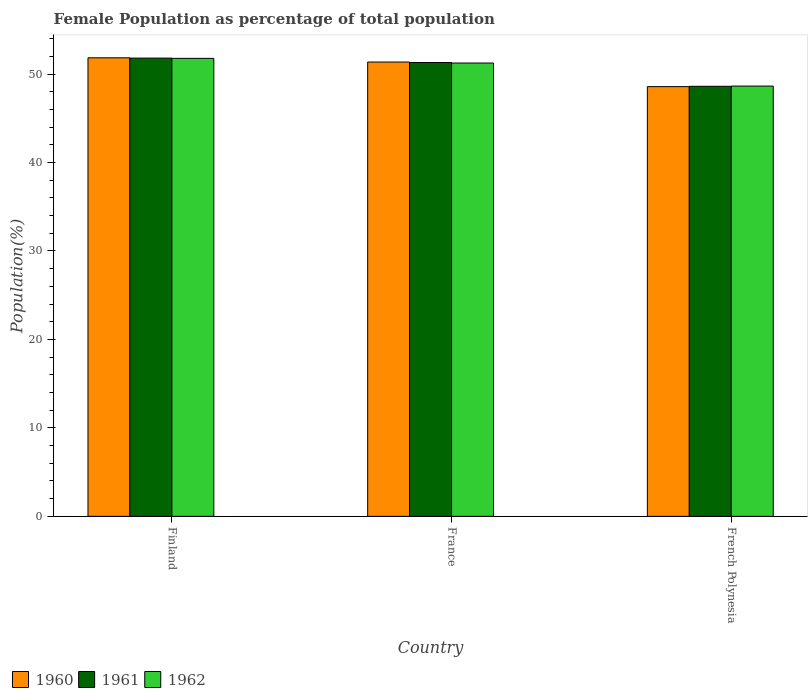How many different coloured bars are there?
Provide a succinct answer. 3. Are the number of bars per tick equal to the number of legend labels?
Your response must be concise. Yes. Are the number of bars on each tick of the X-axis equal?
Keep it short and to the point. Yes. How many bars are there on the 2nd tick from the left?
Provide a short and direct response. 3. How many bars are there on the 3rd tick from the right?
Offer a very short reply. 3. What is the label of the 1st group of bars from the left?
Ensure brevity in your answer.  Finland. What is the female population in in 1962 in France?
Provide a succinct answer. 51.25. Across all countries, what is the maximum female population in in 1960?
Your response must be concise. 51.84. Across all countries, what is the minimum female population in in 1960?
Make the answer very short. 48.58. In which country was the female population in in 1960 maximum?
Ensure brevity in your answer.  Finland. In which country was the female population in in 1962 minimum?
Offer a very short reply. French Polynesia. What is the total female population in in 1961 in the graph?
Offer a very short reply. 151.73. What is the difference between the female population in in 1960 in Finland and that in French Polynesia?
Ensure brevity in your answer.  3.26. What is the difference between the female population in in 1961 in French Polynesia and the female population in in 1962 in Finland?
Make the answer very short. -3.16. What is the average female population in in 1960 per country?
Provide a short and direct response. 50.59. What is the difference between the female population in of/in 1960 and female population in of/in 1962 in Finland?
Your response must be concise. 0.06. What is the ratio of the female population in in 1961 in Finland to that in France?
Your answer should be compact. 1.01. Is the female population in in 1961 in France less than that in French Polynesia?
Your response must be concise. No. Is the difference between the female population in in 1960 in Finland and French Polynesia greater than the difference between the female population in in 1962 in Finland and French Polynesia?
Provide a short and direct response. Yes. What is the difference between the highest and the second highest female population in in 1961?
Your response must be concise. -2.69. What is the difference between the highest and the lowest female population in in 1962?
Provide a short and direct response. 3.13. What does the 1st bar from the left in French Polynesia represents?
Your answer should be very brief. 1960. Is it the case that in every country, the sum of the female population in in 1960 and female population in in 1962 is greater than the female population in in 1961?
Give a very brief answer. Yes. Does the graph contain grids?
Make the answer very short. No. Where does the legend appear in the graph?
Your answer should be very brief. Bottom left. How many legend labels are there?
Provide a short and direct response. 3. What is the title of the graph?
Offer a terse response. Female Population as percentage of total population. What is the label or title of the X-axis?
Offer a terse response. Country. What is the label or title of the Y-axis?
Make the answer very short. Population(%). What is the Population(%) in 1960 in Finland?
Provide a succinct answer. 51.84. What is the Population(%) in 1961 in Finland?
Provide a succinct answer. 51.81. What is the Population(%) of 1962 in Finland?
Give a very brief answer. 51.77. What is the Population(%) in 1960 in France?
Provide a succinct answer. 51.36. What is the Population(%) in 1961 in France?
Your response must be concise. 51.31. What is the Population(%) in 1962 in France?
Offer a terse response. 51.25. What is the Population(%) in 1960 in French Polynesia?
Offer a terse response. 48.58. What is the Population(%) of 1961 in French Polynesia?
Your response must be concise. 48.62. What is the Population(%) in 1962 in French Polynesia?
Give a very brief answer. 48.64. Across all countries, what is the maximum Population(%) of 1960?
Your response must be concise. 51.84. Across all countries, what is the maximum Population(%) of 1961?
Provide a short and direct response. 51.81. Across all countries, what is the maximum Population(%) in 1962?
Offer a very short reply. 51.77. Across all countries, what is the minimum Population(%) of 1960?
Your response must be concise. 48.58. Across all countries, what is the minimum Population(%) of 1961?
Offer a very short reply. 48.62. Across all countries, what is the minimum Population(%) in 1962?
Your answer should be compact. 48.64. What is the total Population(%) in 1960 in the graph?
Keep it short and to the point. 151.78. What is the total Population(%) of 1961 in the graph?
Your answer should be compact. 151.73. What is the total Population(%) of 1962 in the graph?
Provide a succinct answer. 151.67. What is the difference between the Population(%) of 1960 in Finland and that in France?
Ensure brevity in your answer.  0.48. What is the difference between the Population(%) of 1961 in Finland and that in France?
Keep it short and to the point. 0.5. What is the difference between the Population(%) of 1962 in Finland and that in France?
Your answer should be compact. 0.53. What is the difference between the Population(%) of 1960 in Finland and that in French Polynesia?
Provide a succinct answer. 3.26. What is the difference between the Population(%) in 1961 in Finland and that in French Polynesia?
Offer a very short reply. 3.19. What is the difference between the Population(%) in 1962 in Finland and that in French Polynesia?
Provide a succinct answer. 3.13. What is the difference between the Population(%) of 1960 in France and that in French Polynesia?
Provide a short and direct response. 2.78. What is the difference between the Population(%) of 1961 in France and that in French Polynesia?
Your answer should be compact. 2.69. What is the difference between the Population(%) in 1962 in France and that in French Polynesia?
Your response must be concise. 2.61. What is the difference between the Population(%) in 1960 in Finland and the Population(%) in 1961 in France?
Your answer should be very brief. 0.53. What is the difference between the Population(%) of 1960 in Finland and the Population(%) of 1962 in France?
Give a very brief answer. 0.59. What is the difference between the Population(%) in 1961 in Finland and the Population(%) in 1962 in France?
Keep it short and to the point. 0.56. What is the difference between the Population(%) of 1960 in Finland and the Population(%) of 1961 in French Polynesia?
Keep it short and to the point. 3.22. What is the difference between the Population(%) in 1960 in Finland and the Population(%) in 1962 in French Polynesia?
Provide a succinct answer. 3.2. What is the difference between the Population(%) in 1961 in Finland and the Population(%) in 1962 in French Polynesia?
Your response must be concise. 3.16. What is the difference between the Population(%) in 1960 in France and the Population(%) in 1961 in French Polynesia?
Your answer should be compact. 2.74. What is the difference between the Population(%) in 1960 in France and the Population(%) in 1962 in French Polynesia?
Your response must be concise. 2.72. What is the difference between the Population(%) of 1961 in France and the Population(%) of 1962 in French Polynesia?
Ensure brevity in your answer.  2.66. What is the average Population(%) of 1960 per country?
Offer a very short reply. 50.59. What is the average Population(%) in 1961 per country?
Give a very brief answer. 50.58. What is the average Population(%) of 1962 per country?
Keep it short and to the point. 50.56. What is the difference between the Population(%) in 1960 and Population(%) in 1961 in Finland?
Make the answer very short. 0.03. What is the difference between the Population(%) in 1960 and Population(%) in 1962 in Finland?
Give a very brief answer. 0.06. What is the difference between the Population(%) of 1961 and Population(%) of 1962 in Finland?
Provide a succinct answer. 0.03. What is the difference between the Population(%) in 1960 and Population(%) in 1961 in France?
Your answer should be compact. 0.05. What is the difference between the Population(%) of 1960 and Population(%) of 1962 in France?
Make the answer very short. 0.11. What is the difference between the Population(%) in 1961 and Population(%) in 1962 in France?
Offer a very short reply. 0.06. What is the difference between the Population(%) in 1960 and Population(%) in 1961 in French Polynesia?
Your answer should be compact. -0.04. What is the difference between the Population(%) of 1960 and Population(%) of 1962 in French Polynesia?
Make the answer very short. -0.06. What is the difference between the Population(%) in 1961 and Population(%) in 1962 in French Polynesia?
Your response must be concise. -0.02. What is the ratio of the Population(%) of 1960 in Finland to that in France?
Your response must be concise. 1.01. What is the ratio of the Population(%) of 1961 in Finland to that in France?
Provide a short and direct response. 1.01. What is the ratio of the Population(%) of 1962 in Finland to that in France?
Ensure brevity in your answer.  1.01. What is the ratio of the Population(%) of 1960 in Finland to that in French Polynesia?
Ensure brevity in your answer.  1.07. What is the ratio of the Population(%) of 1961 in Finland to that in French Polynesia?
Make the answer very short. 1.07. What is the ratio of the Population(%) in 1962 in Finland to that in French Polynesia?
Your answer should be very brief. 1.06. What is the ratio of the Population(%) of 1960 in France to that in French Polynesia?
Your response must be concise. 1.06. What is the ratio of the Population(%) of 1961 in France to that in French Polynesia?
Give a very brief answer. 1.06. What is the ratio of the Population(%) in 1962 in France to that in French Polynesia?
Make the answer very short. 1.05. What is the difference between the highest and the second highest Population(%) in 1960?
Give a very brief answer. 0.48. What is the difference between the highest and the second highest Population(%) of 1961?
Make the answer very short. 0.5. What is the difference between the highest and the second highest Population(%) in 1962?
Offer a terse response. 0.53. What is the difference between the highest and the lowest Population(%) of 1960?
Make the answer very short. 3.26. What is the difference between the highest and the lowest Population(%) in 1961?
Provide a short and direct response. 3.19. What is the difference between the highest and the lowest Population(%) of 1962?
Offer a very short reply. 3.13. 